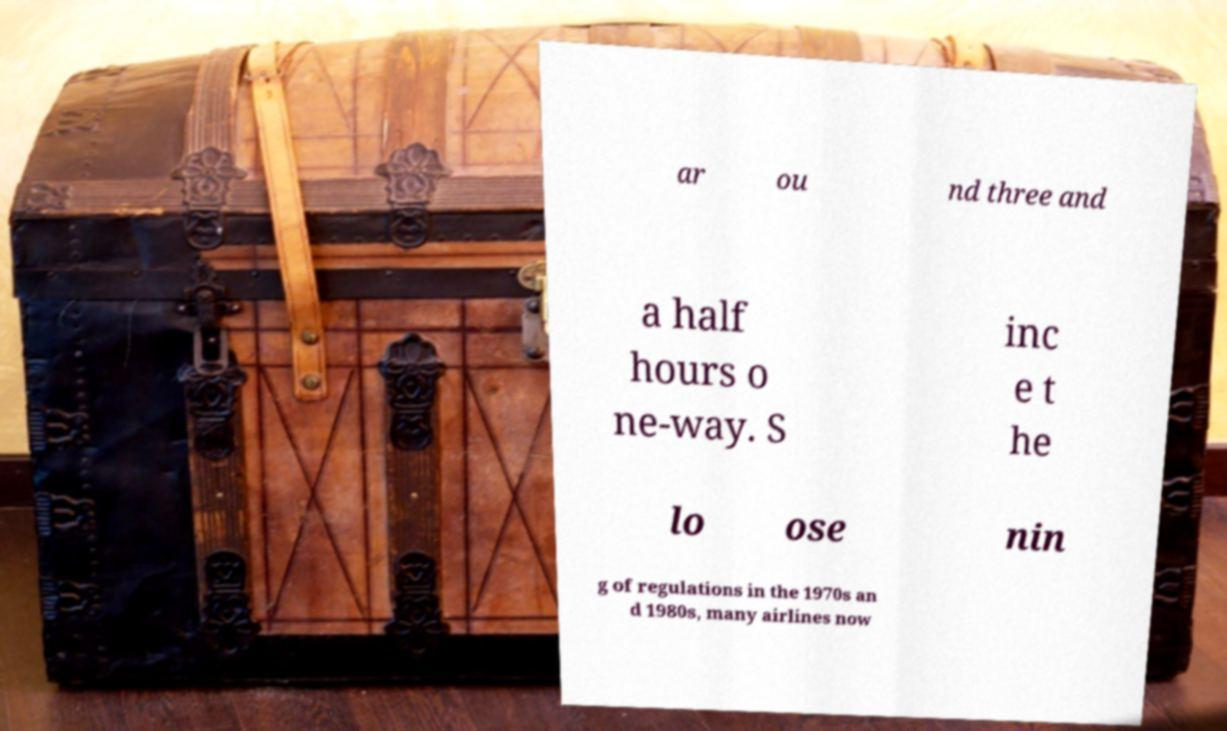Could you assist in decoding the text presented in this image and type it out clearly? ar ou nd three and a half hours o ne-way. S inc e t he lo ose nin g of regulations in the 1970s an d 1980s, many airlines now 